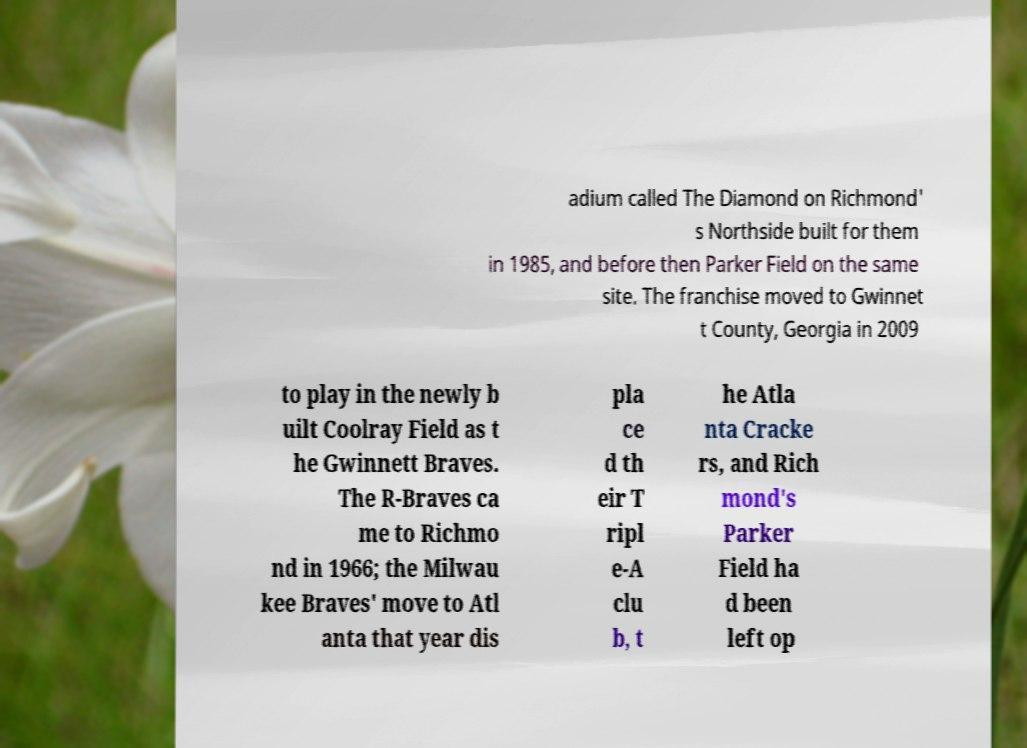Please identify and transcribe the text found in this image. adium called The Diamond on Richmond' s Northside built for them in 1985, and before then Parker Field on the same site. The franchise moved to Gwinnet t County, Georgia in 2009 to play in the newly b uilt Coolray Field as t he Gwinnett Braves. The R-Braves ca me to Richmo nd in 1966; the Milwau kee Braves' move to Atl anta that year dis pla ce d th eir T ripl e-A clu b, t he Atla nta Cracke rs, and Rich mond's Parker Field ha d been left op 